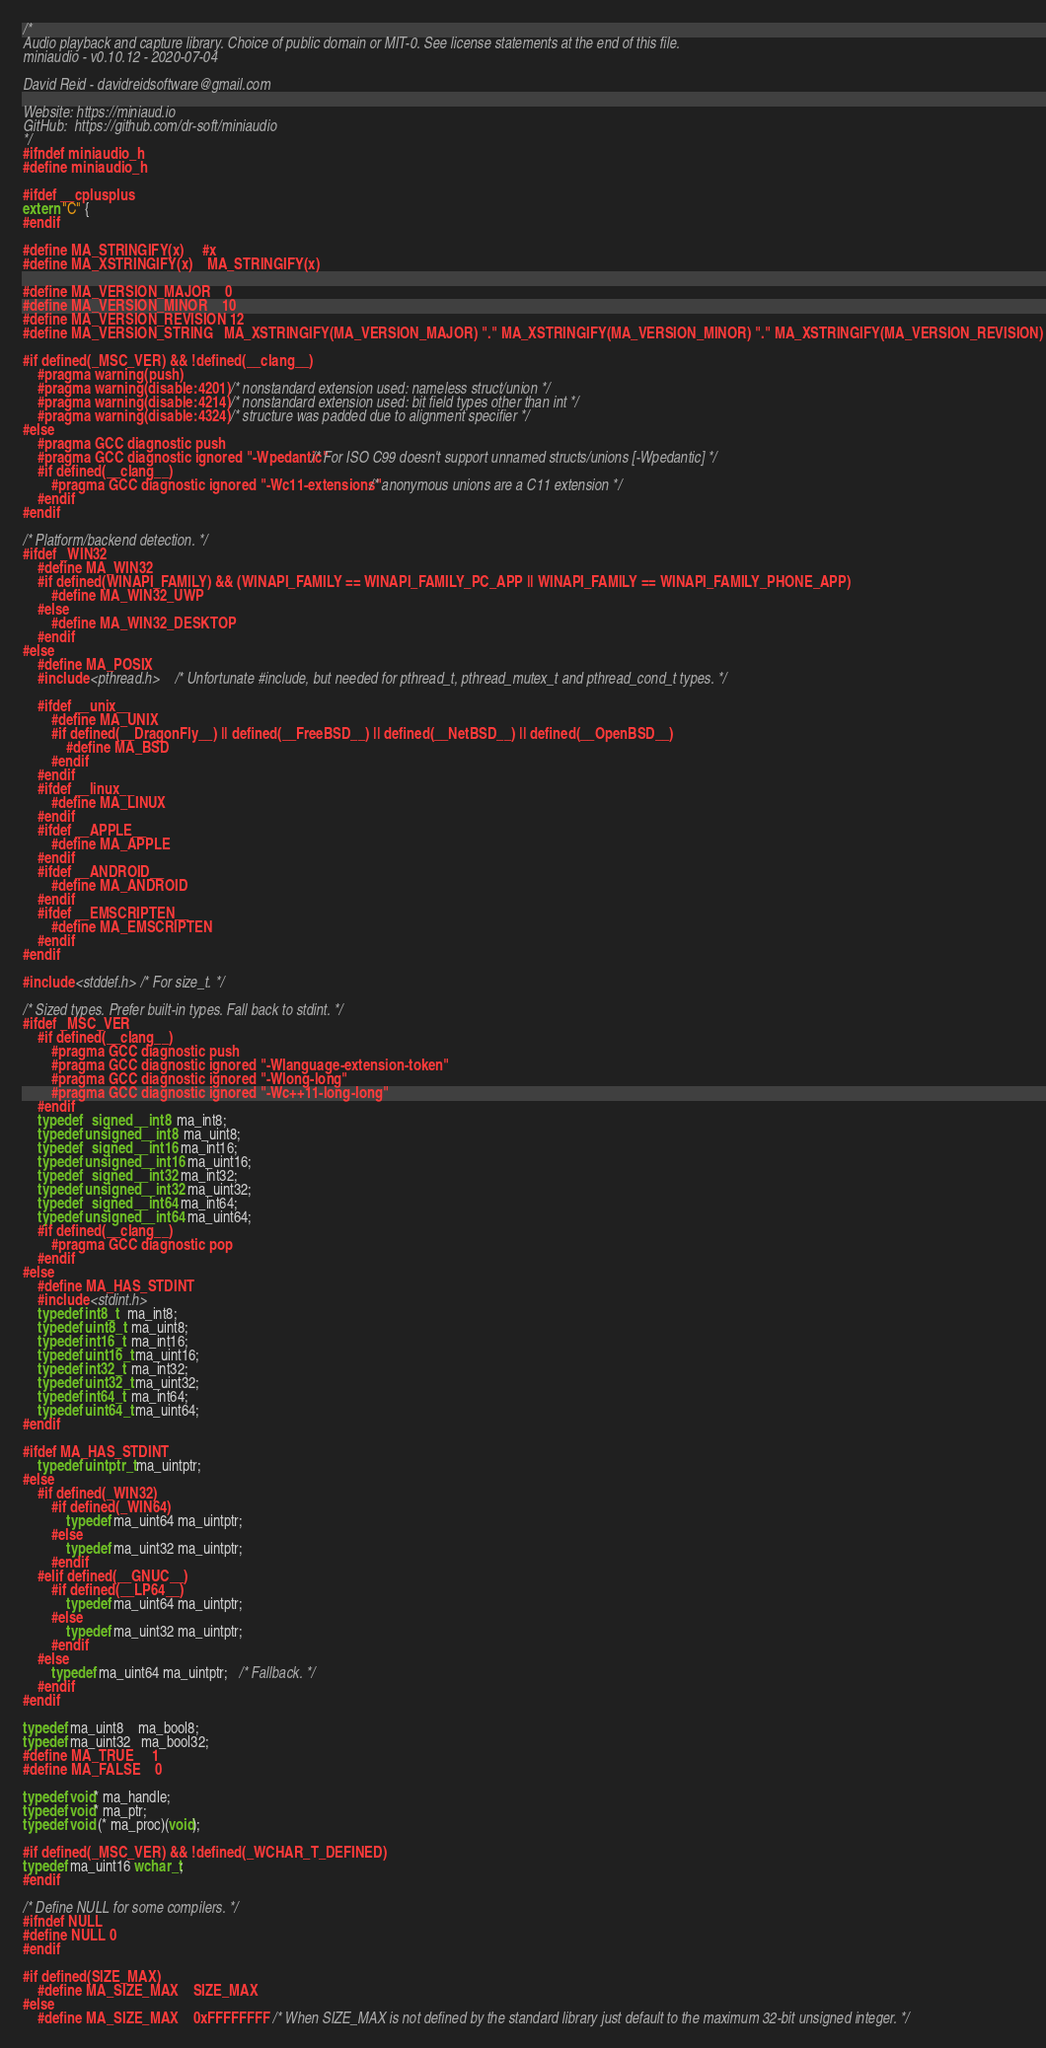<code> <loc_0><loc_0><loc_500><loc_500><_C_>/*
Audio playback and capture library. Choice of public domain or MIT-0. See license statements at the end of this file.
miniaudio - v0.10.12 - 2020-07-04

David Reid - davidreidsoftware@gmail.com

Website: https://miniaud.io
GitHub:  https://github.com/dr-soft/miniaudio
*/
#ifndef miniaudio_h
#define miniaudio_h

#ifdef __cplusplus
extern "C" {
#endif

#define MA_STRINGIFY(x)     #x
#define MA_XSTRINGIFY(x)    MA_STRINGIFY(x)

#define MA_VERSION_MAJOR    0
#define MA_VERSION_MINOR    10
#define MA_VERSION_REVISION 12
#define MA_VERSION_STRING   MA_XSTRINGIFY(MA_VERSION_MAJOR) "." MA_XSTRINGIFY(MA_VERSION_MINOR) "." MA_XSTRINGIFY(MA_VERSION_REVISION)

#if defined(_MSC_VER) && !defined(__clang__)
    #pragma warning(push)
    #pragma warning(disable:4201)   /* nonstandard extension used: nameless struct/union */
    #pragma warning(disable:4214)   /* nonstandard extension used: bit field types other than int */
    #pragma warning(disable:4324)   /* structure was padded due to alignment specifier */
#else
    #pragma GCC diagnostic push
    #pragma GCC diagnostic ignored "-Wpedantic" /* For ISO C99 doesn't support unnamed structs/unions [-Wpedantic] */
    #if defined(__clang__)
        #pragma GCC diagnostic ignored "-Wc11-extensions"   /* anonymous unions are a C11 extension */
    #endif
#endif

/* Platform/backend detection. */
#ifdef _WIN32
    #define MA_WIN32
    #if defined(WINAPI_FAMILY) && (WINAPI_FAMILY == WINAPI_FAMILY_PC_APP || WINAPI_FAMILY == WINAPI_FAMILY_PHONE_APP)
        #define MA_WIN32_UWP
    #else
        #define MA_WIN32_DESKTOP
    #endif
#else
    #define MA_POSIX
    #include <pthread.h>    /* Unfortunate #include, but needed for pthread_t, pthread_mutex_t and pthread_cond_t types. */

    #ifdef __unix__
        #define MA_UNIX
        #if defined(__DragonFly__) || defined(__FreeBSD__) || defined(__NetBSD__) || defined(__OpenBSD__)
            #define MA_BSD
        #endif
    #endif
    #ifdef __linux__
        #define MA_LINUX
    #endif
    #ifdef __APPLE__
        #define MA_APPLE
    #endif
    #ifdef __ANDROID__
        #define MA_ANDROID
    #endif
    #ifdef __EMSCRIPTEN__
        #define MA_EMSCRIPTEN
    #endif
#endif

#include <stddef.h> /* For size_t. */

/* Sized types. Prefer built-in types. Fall back to stdint. */
#ifdef _MSC_VER
    #if defined(__clang__)
        #pragma GCC diagnostic push
        #pragma GCC diagnostic ignored "-Wlanguage-extension-token"
        #pragma GCC diagnostic ignored "-Wlong-long"
        #pragma GCC diagnostic ignored "-Wc++11-long-long"
    #endif
    typedef   signed __int8  ma_int8;
    typedef unsigned __int8  ma_uint8;
    typedef   signed __int16 ma_int16;
    typedef unsigned __int16 ma_uint16;
    typedef   signed __int32 ma_int32;
    typedef unsigned __int32 ma_uint32;
    typedef   signed __int64 ma_int64;
    typedef unsigned __int64 ma_uint64;
    #if defined(__clang__)
        #pragma GCC diagnostic pop
    #endif
#else
    #define MA_HAS_STDINT
    #include <stdint.h>
    typedef int8_t   ma_int8;
    typedef uint8_t  ma_uint8;
    typedef int16_t  ma_int16;
    typedef uint16_t ma_uint16;
    typedef int32_t  ma_int32;
    typedef uint32_t ma_uint32;
    typedef int64_t  ma_int64;
    typedef uint64_t ma_uint64;
#endif

#ifdef MA_HAS_STDINT
    typedef uintptr_t ma_uintptr;
#else
    #if defined(_WIN32)
        #if defined(_WIN64)
            typedef ma_uint64 ma_uintptr;
        #else
            typedef ma_uint32 ma_uintptr;
        #endif
    #elif defined(__GNUC__)
        #if defined(__LP64__)
            typedef ma_uint64 ma_uintptr;
        #else
            typedef ma_uint32 ma_uintptr;
        #endif
    #else
        typedef ma_uint64 ma_uintptr;   /* Fallback. */
    #endif
#endif

typedef ma_uint8    ma_bool8;
typedef ma_uint32   ma_bool32;
#define MA_TRUE     1
#define MA_FALSE    0

typedef void* ma_handle;
typedef void* ma_ptr;
typedef void (* ma_proc)(void);

#if defined(_MSC_VER) && !defined(_WCHAR_T_DEFINED)
typedef ma_uint16 wchar_t;
#endif

/* Define NULL for some compilers. */
#ifndef NULL
#define NULL 0
#endif

#if defined(SIZE_MAX)
    #define MA_SIZE_MAX    SIZE_MAX
#else
    #define MA_SIZE_MAX    0xFFFFFFFF  /* When SIZE_MAX is not defined by the standard library just default to the maximum 32-bit unsigned integer. */</code> 